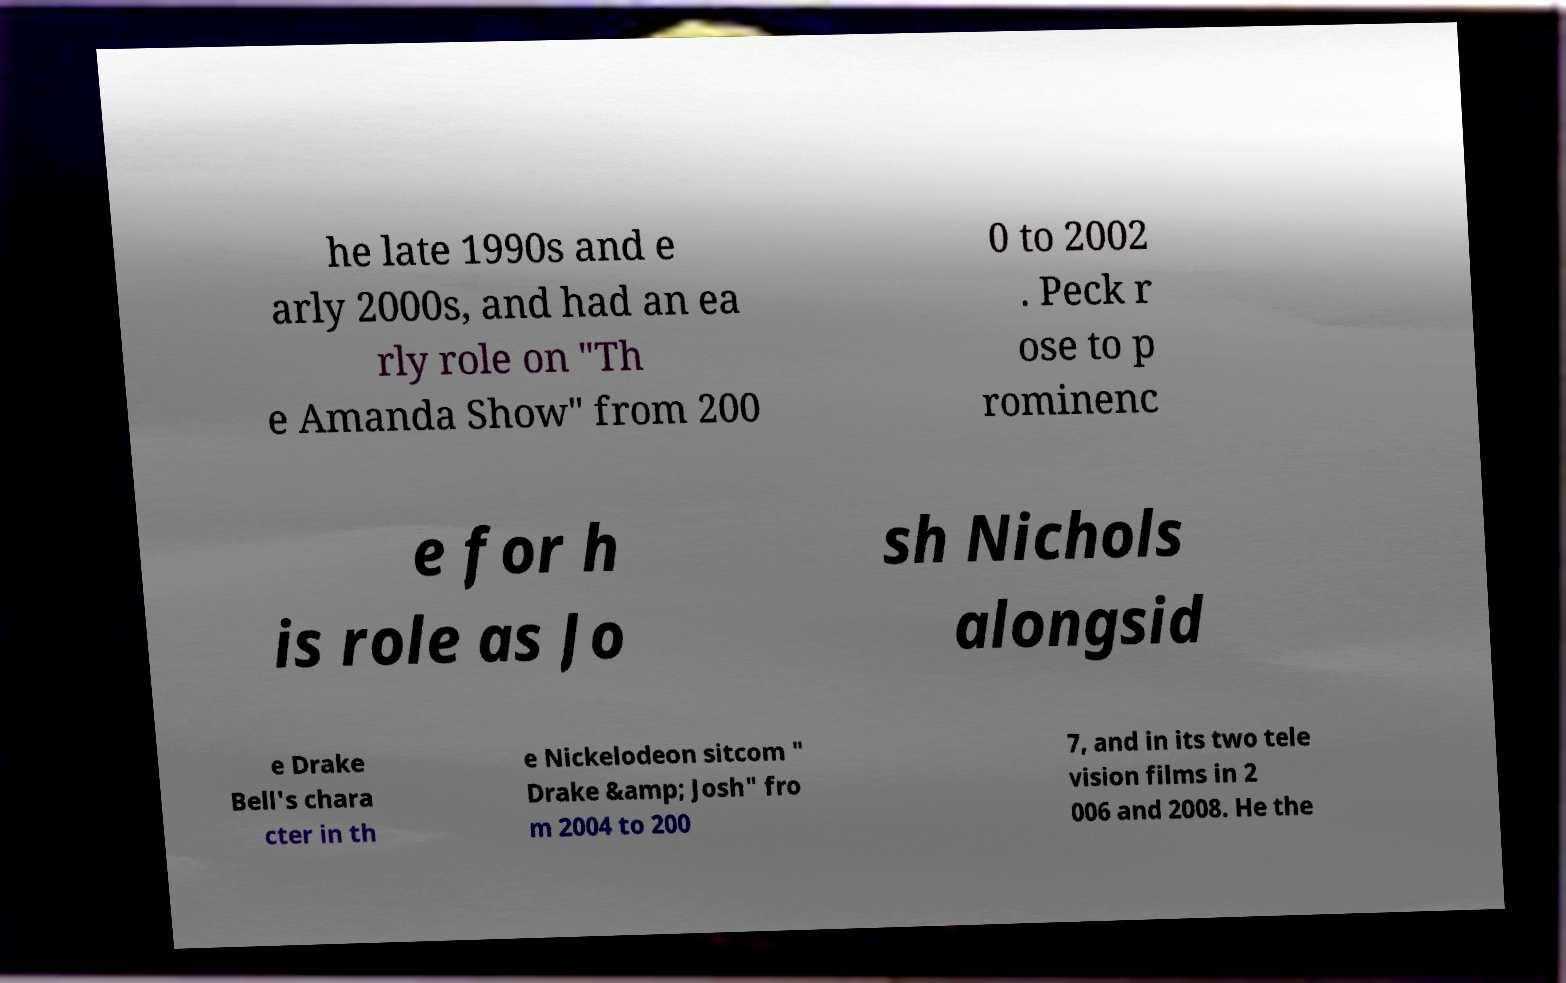For documentation purposes, I need the text within this image transcribed. Could you provide that? he late 1990s and e arly 2000s, and had an ea rly role on "Th e Amanda Show" from 200 0 to 2002 . Peck r ose to p rominenc e for h is role as Jo sh Nichols alongsid e Drake Bell's chara cter in th e Nickelodeon sitcom " Drake &amp; Josh" fro m 2004 to 200 7, and in its two tele vision films in 2 006 and 2008. He the 